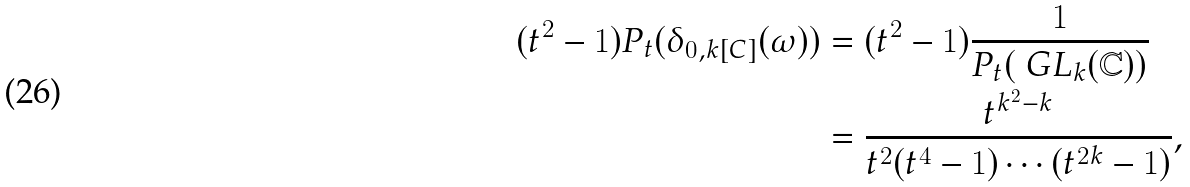Convert formula to latex. <formula><loc_0><loc_0><loc_500><loc_500>( t ^ { 2 } - 1 ) P _ { t } ( \delta _ { 0 , k [ C ] } ( \omega ) ) & = ( t ^ { 2 } - 1 ) \frac { 1 } { P _ { t } ( \ G L _ { k } ( \mathbb { C } ) ) } \\ & = \frac { t ^ { k ^ { 2 } - k } } { t ^ { 2 } ( t ^ { 4 } - 1 ) \cdots ( t ^ { 2 k } - 1 ) } ,</formula> 